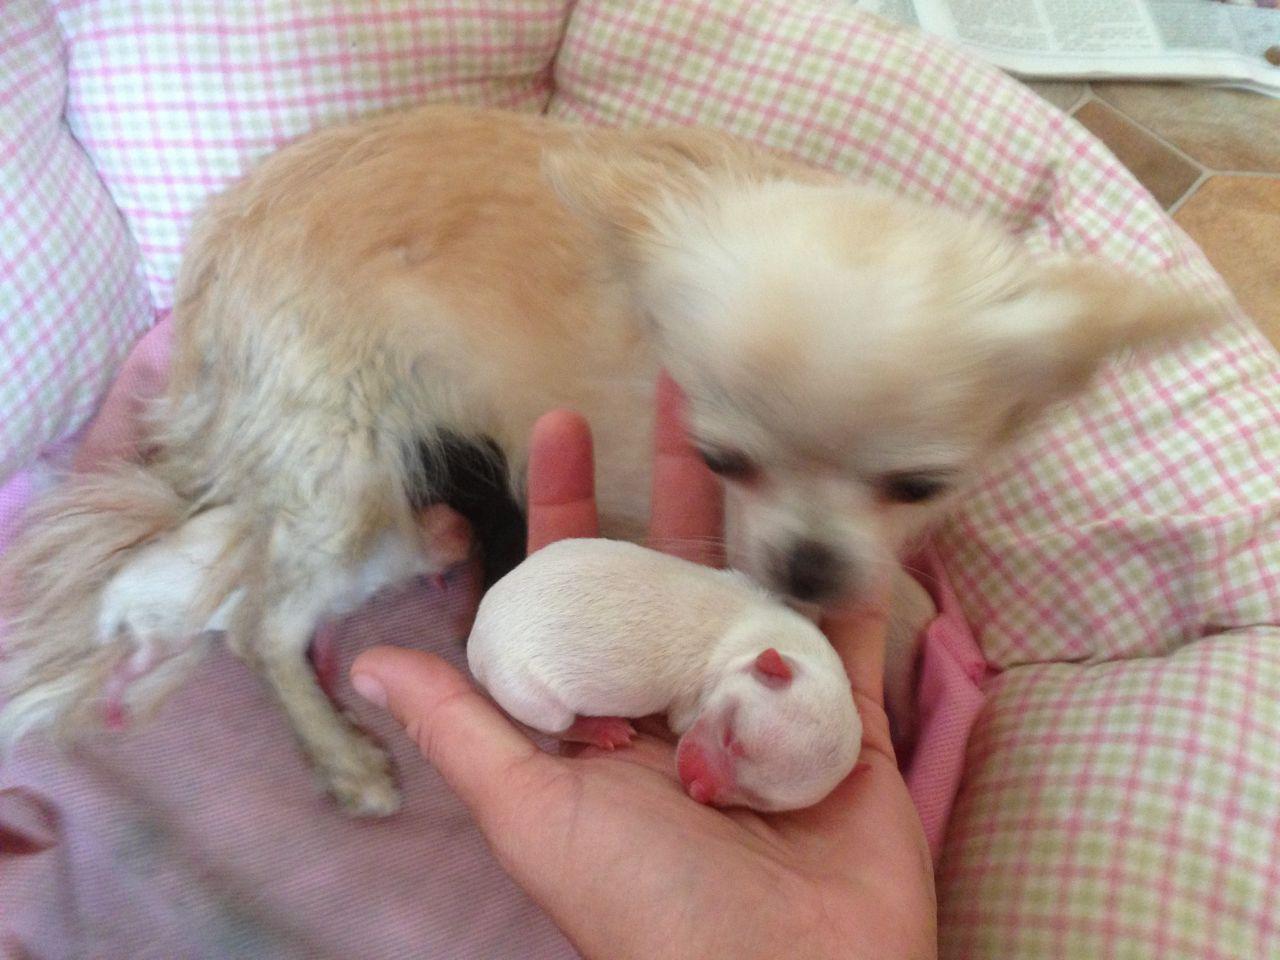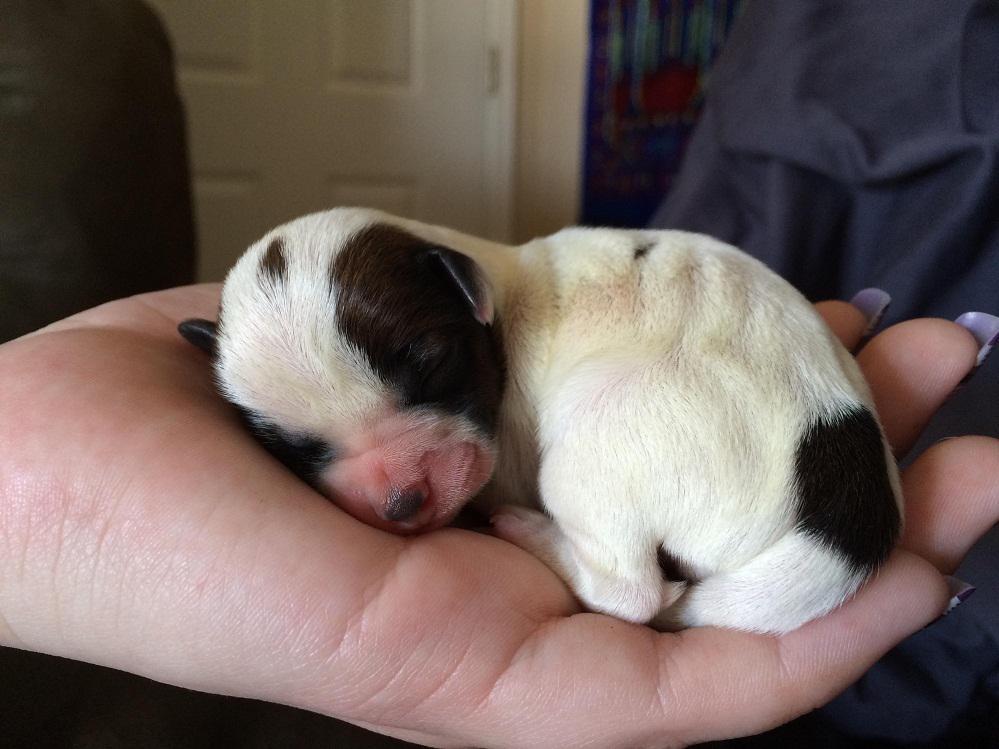The first image is the image on the left, the second image is the image on the right. Assess this claim about the two images: "At least one image shows a tiny puppy with closed eyes, held in the palm of a hand.". Correct or not? Answer yes or no. Yes. The first image is the image on the left, the second image is the image on the right. Considering the images on both sides, is "Someone is holding at least one of the animals in all of the images." valid? Answer yes or no. Yes. 